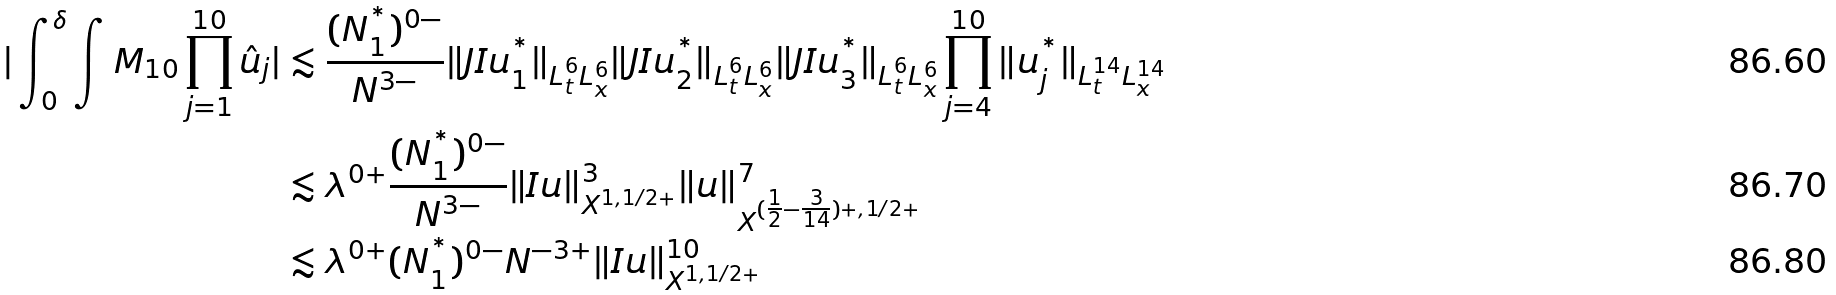<formula> <loc_0><loc_0><loc_500><loc_500>| \int _ { 0 } ^ { \delta } \int M _ { 1 0 } \prod _ { j = 1 } ^ { 1 0 } \hat { u } _ { j } | & \lesssim \frac { ( N _ { 1 } ^ { ^ { * } } ) ^ { 0 - } } { N ^ { 3 - } } \| J I u _ { 1 } ^ { ^ { * } } \| _ { L _ { t } ^ { 6 } L _ { x } ^ { 6 } } \| J I u _ { 2 } ^ { ^ { * } } \| _ { L _ { t } ^ { 6 } L _ { x } ^ { 6 } } \| J I u _ { 3 } ^ { ^ { * } } \| _ { L _ { t } ^ { 6 } L _ { x } ^ { 6 } } \prod _ { j = 4 } ^ { 1 0 } \| u _ { j } ^ { ^ { * } } \| _ { L _ { t } ^ { 1 4 } L _ { x } ^ { 1 4 } } \\ & \lesssim \lambda ^ { 0 + } \frac { ( N _ { 1 } ^ { ^ { * } } ) ^ { 0 - } } { N ^ { 3 - } } \| I u \| _ { X ^ { 1 , 1 / 2 + } } ^ { 3 } \| u \| _ { X ^ { ( \frac { 1 } { 2 } - \frac { 3 } { 1 4 } ) + , 1 / 2 + } } ^ { 7 } \\ & \lesssim \lambda ^ { 0 + } ( N _ { 1 } ^ { ^ { * } } ) ^ { 0 - } N ^ { - 3 + } \| I u \| _ { X ^ { 1 , 1 / 2 + } } ^ { 1 0 }</formula> 